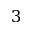Convert formula to latex. <formula><loc_0><loc_0><loc_500><loc_500>3</formula> 